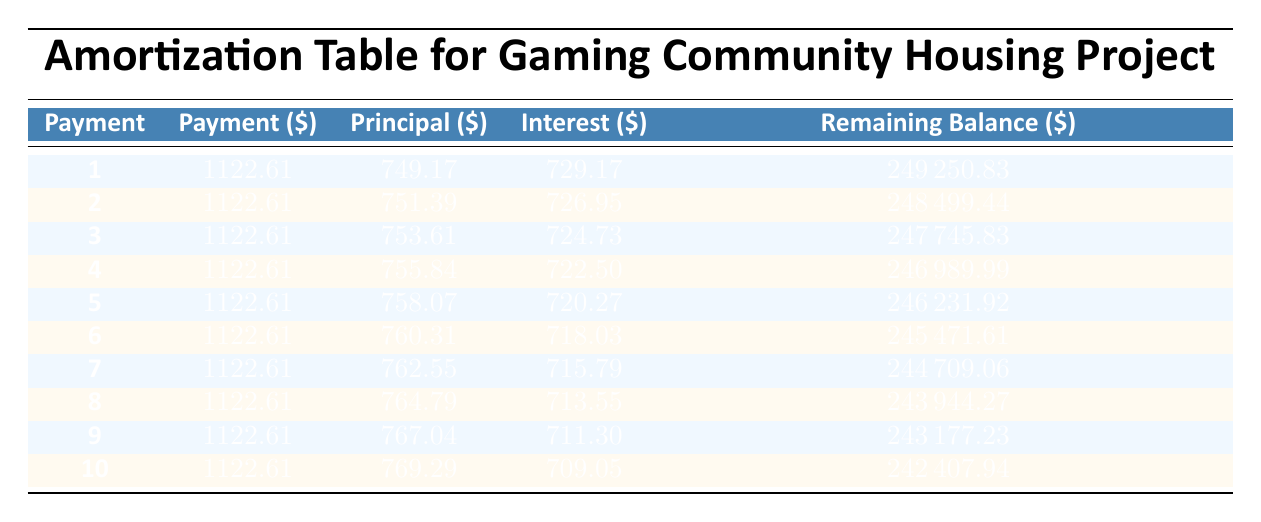What is the monthly payment for the mortgage? The monthly payment is specified in the table as 1122.61.
Answer: 1122.61 How much principal is paid in the first month? The principal payment in the first month is listed in the table as 749.17.
Answer: 749.17 Is the interest payment decreasing with each consecutive month in the table? Yes, the table shows that the interest payment decreases as it starts at 729.17 in the first month and decreases in subsequent months.
Answer: Yes What is the total interest paid in the first three months? To find the total interest paid in the first three months, sum the interest payments for those months: 729.17 + 726.95 + 724.73 = 2180.85.
Answer: 2180.85 What is the remaining balance after the fifth payment? Looking at the table, the remaining balance after the fifth payment is listed as 246231.92.
Answer: 246231.92 In which month is the principal payment highest within the first ten months? The highest principal payment in the first ten months is found in the tenth month at 769.29.
Answer: 769.29 Are the principal payments increasing consistently every month? Yes, the principal payments increase consistently from 749.17 in the first month to 769.29 in the tenth month.
Answer: Yes What is the change in remaining balance from the first to the second payment? The remaining balance after the first payment is 249250.83 and after the second payment is 248499.44. The change is calculated as 249250.83 - 248499.44 = 751.39, which is exactly the principal amount paid in the second month.
Answer: 751.39 By what percentage did the remaining balance decrease from the first to the second month? The decrease in remaining balance from the first month (249250.83) to the second month (248499.44) is 249250.83 - 248499.44 = 751.39. The percentage decrease is calculated by (751.39 / 249250.83) * 100 ≈ 0.301%.
Answer: 0.301% 